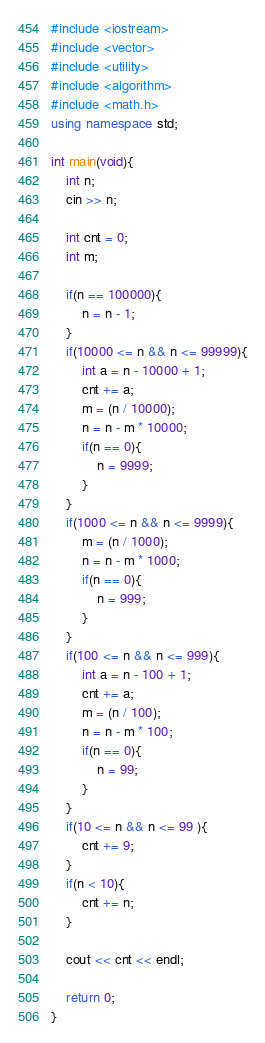Convert code to text. <code><loc_0><loc_0><loc_500><loc_500><_C++_>#include <iostream>
#include <vector>
#include <utility>
#include <algorithm>
#include <math.h>
using namespace std;

int main(void){
    int n;
    cin >> n;

    int cnt = 0;
    int m;

    if(n == 100000){
        n = n - 1;
    }
    if(10000 <= n && n <= 99999){
        int a = n - 10000 + 1;
        cnt += a;
        m = (n / 10000);
        n = n - m * 10000;
        if(n == 0){
            n = 9999;
        }
    }
    if(1000 <= n && n <= 9999){
        m = (n / 1000);
        n = n - m * 1000;
        if(n == 0){
            n = 999;
        }
    }
    if(100 <= n && n <= 999){
        int a = n - 100 + 1;
        cnt += a;
        m = (n / 100);
        n = n - m * 100;
        if(n == 0){
            n = 99;
        }
    }
    if(10 <= n && n <= 99 ){
        cnt += 9;
    }
    if(n < 10){
        cnt += n;
    }

    cout << cnt << endl;
    
    return 0;
}</code> 